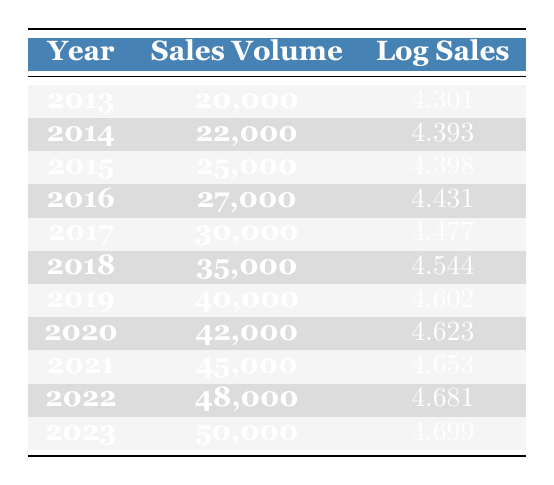What was the sales volume in 2019? The table shows that the sales volume for the year 2019 is listed directly in the corresponding row. For 2019, the sales volume is 40,000.
Answer: 40,000 What is the log sales value for 2020? The log sales for the year 2020 is provided in the table. It can be found in the row for 2020, which states the log sales value as 4.623.
Answer: 4.623 What was the increase in sales volume from 2018 to 2023? To find the increase, we need to subtract the sales volume of 2018 from that of 2023. The sales volume in 2018 is 35,000 and in 2023 is 50,000. The calculation is 50,000 - 35,000 = 15,000.
Answer: 15,000 Was the sales volume in 2015 greater than that of 2014? The sales volume for 2014 is 22,000 and for 2015 is 25,000. Comparing these two values, 25,000 (2015) is indeed greater than 22,000 (2014).
Answer: Yes What is the average log sales value from 2013 to 2022? To find the average, we first add the log sales values from 2013 to 2022: (4.301 + 4.393 + 4.398 + 4.431 + 4.477 + 4.544 + 4.602 + 4.623 + 4.653 + 4.681). This totals to 44.19. We then divide this sum by the number of years, which is 10. Thus, the average log sales value is 44.19 / 10 = 4.419.
Answer: 4.419 How many years had sales volumes greater than 30,000? Looking at the table, the years with sales volumes greater than 30,000 are 2017 (30,000), 2018 (35,000), 2019 (40,000), 2020 (42,000), 2021 (45,000), 2022 (48,000), and 2023 (50,000). Counting those, we find there are 7 years.
Answer: 7 What was the highest sales volume recorded in the data? By examining the sales volume values in the table, the highest sales volume is found in the most recent year, 2023, which is 50,000.
Answer: 50,000 Is the log sales value increasing consistently each year? To determine if log sales is consistently increasing, we can analyze the values year by year. From 2013 (4.301) to 2023 (4.699), each year has a higher log sales value than the previous year, indicating consistent growth.
Answer: Yes 